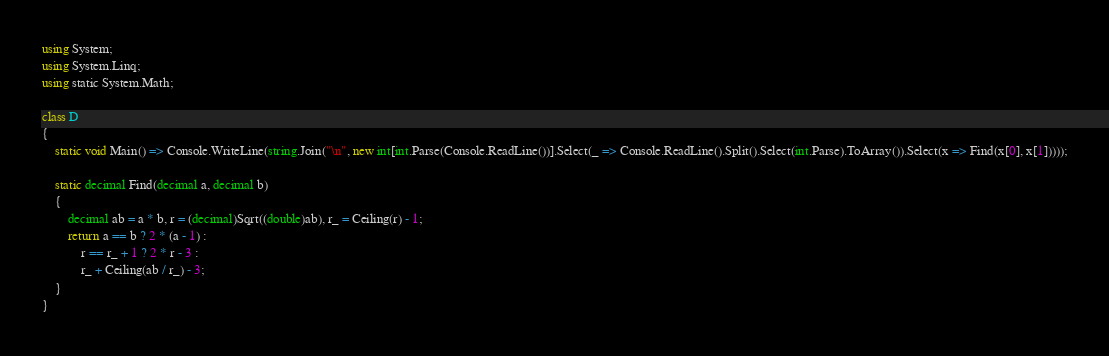<code> <loc_0><loc_0><loc_500><loc_500><_C#_>using System;
using System.Linq;
using static System.Math;

class D
{
	static void Main() => Console.WriteLine(string.Join("\n", new int[int.Parse(Console.ReadLine())].Select(_ => Console.ReadLine().Split().Select(int.Parse).ToArray()).Select(x => Find(x[0], x[1]))));

	static decimal Find(decimal a, decimal b)
	{
		decimal ab = a * b, r = (decimal)Sqrt((double)ab), r_ = Ceiling(r) - 1;
		return a == b ? 2 * (a - 1) :
			r == r_ + 1 ? 2 * r - 3 :
			r_ + Ceiling(ab / r_) - 3;
	}
}
</code> 